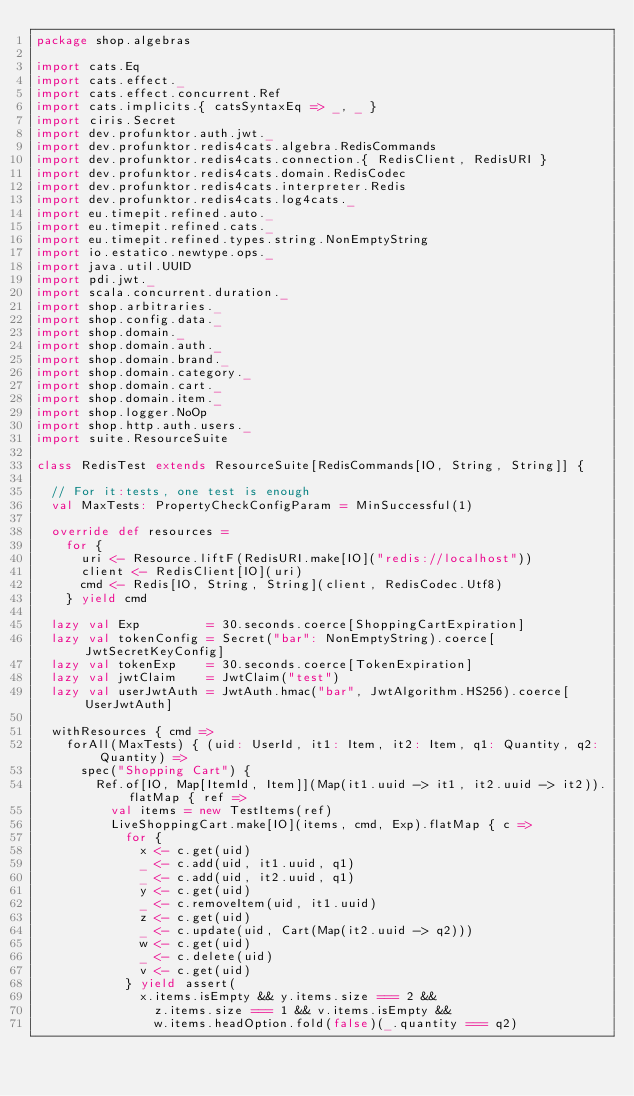Convert code to text. <code><loc_0><loc_0><loc_500><loc_500><_Scala_>package shop.algebras

import cats.Eq
import cats.effect._
import cats.effect.concurrent.Ref
import cats.implicits.{ catsSyntaxEq => _, _ }
import ciris.Secret
import dev.profunktor.auth.jwt._
import dev.profunktor.redis4cats.algebra.RedisCommands
import dev.profunktor.redis4cats.connection.{ RedisClient, RedisURI }
import dev.profunktor.redis4cats.domain.RedisCodec
import dev.profunktor.redis4cats.interpreter.Redis
import dev.profunktor.redis4cats.log4cats._
import eu.timepit.refined.auto._
import eu.timepit.refined.cats._
import eu.timepit.refined.types.string.NonEmptyString
import io.estatico.newtype.ops._
import java.util.UUID
import pdi.jwt._
import scala.concurrent.duration._
import shop.arbitraries._
import shop.config.data._
import shop.domain._
import shop.domain.auth._
import shop.domain.brand._
import shop.domain.category._
import shop.domain.cart._
import shop.domain.item._
import shop.logger.NoOp
import shop.http.auth.users._
import suite.ResourceSuite

class RedisTest extends ResourceSuite[RedisCommands[IO, String, String]] {

  // For it:tests, one test is enough
  val MaxTests: PropertyCheckConfigParam = MinSuccessful(1)

  override def resources =
    for {
      uri <- Resource.liftF(RedisURI.make[IO]("redis://localhost"))
      client <- RedisClient[IO](uri)
      cmd <- Redis[IO, String, String](client, RedisCodec.Utf8)
    } yield cmd

  lazy val Exp         = 30.seconds.coerce[ShoppingCartExpiration]
  lazy val tokenConfig = Secret("bar": NonEmptyString).coerce[JwtSecretKeyConfig]
  lazy val tokenExp    = 30.seconds.coerce[TokenExpiration]
  lazy val jwtClaim    = JwtClaim("test")
  lazy val userJwtAuth = JwtAuth.hmac("bar", JwtAlgorithm.HS256).coerce[UserJwtAuth]

  withResources { cmd =>
    forAll(MaxTests) { (uid: UserId, it1: Item, it2: Item, q1: Quantity, q2: Quantity) =>
      spec("Shopping Cart") {
        Ref.of[IO, Map[ItemId, Item]](Map(it1.uuid -> it1, it2.uuid -> it2)).flatMap { ref =>
          val items = new TestItems(ref)
          LiveShoppingCart.make[IO](items, cmd, Exp).flatMap { c =>
            for {
              x <- c.get(uid)
              _ <- c.add(uid, it1.uuid, q1)
              _ <- c.add(uid, it2.uuid, q1)
              y <- c.get(uid)
              _ <- c.removeItem(uid, it1.uuid)
              z <- c.get(uid)
              _ <- c.update(uid, Cart(Map(it2.uuid -> q2)))
              w <- c.get(uid)
              _ <- c.delete(uid)
              v <- c.get(uid)
            } yield assert(
              x.items.isEmpty && y.items.size === 2 &&
                z.items.size === 1 && v.items.isEmpty &&
                w.items.headOption.fold(false)(_.quantity === q2)</code> 